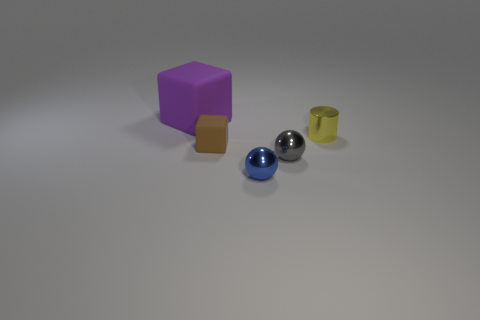How many tiny blue shiny things have the same shape as the tiny gray thing? There is one small blue shiny sphere that shares the same shape as the tiny gray sphere in the image. 